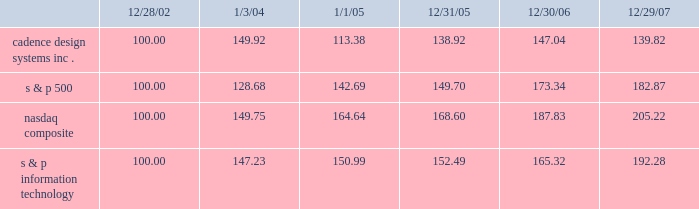The graph below matches cadence design systems , inc . 2019s cumulative 5-year total shareholder return on common stock with the cumulative total returns of the s&p 500 index , the s&p information technology index , and the nasdaq composite index .
The graph assumes that the value of the investment in our common stock , and in each index ( including reinvestment of dividends ) was $ 100 on december 28 , 2002 and tracks it through december 29 , 2007 .
Comparison of 5 year cumulative total return* among cadence design systems , inc. , the s&p 500 index , the nasdaq composite index and the s&p information technology index 12/29/0712/30/0612/31/051/1/051/3/0412/28/02 cadence design systems , inc .
Nasdaq composite s & p information technology s & p 500 * $ 100 invested on 12/28/02 in stock or on 12/31/02 in index-including reinvestment of dividends .
Indexes calculated on month-end basis .
Copyright b7 2007 , standard & poor 2019s , a division of the mcgraw-hill companies , inc .
All rights reserved .
Www.researchdatagroup.com/s&p.htm .
The stock price performance included in this graph is not necessarily indicative of future stock price performance .
What was the percentage cadence design systems , inc . 2019s cumulative 5-year total shareholder return on common stock for the period ending 12/29/07? 
Computations: ((139.82 - 100) / 100)
Answer: 0.3982. 